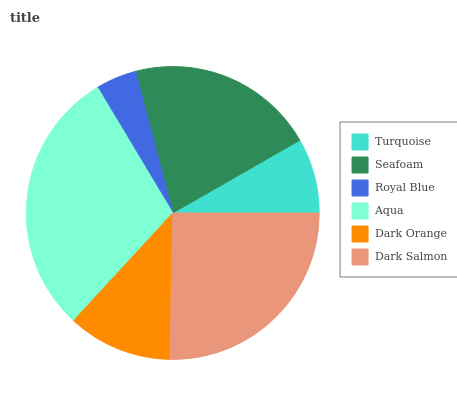Is Royal Blue the minimum?
Answer yes or no. Yes. Is Aqua the maximum?
Answer yes or no. Yes. Is Seafoam the minimum?
Answer yes or no. No. Is Seafoam the maximum?
Answer yes or no. No. Is Seafoam greater than Turquoise?
Answer yes or no. Yes. Is Turquoise less than Seafoam?
Answer yes or no. Yes. Is Turquoise greater than Seafoam?
Answer yes or no. No. Is Seafoam less than Turquoise?
Answer yes or no. No. Is Seafoam the high median?
Answer yes or no. Yes. Is Dark Orange the low median?
Answer yes or no. Yes. Is Royal Blue the high median?
Answer yes or no. No. Is Seafoam the low median?
Answer yes or no. No. 